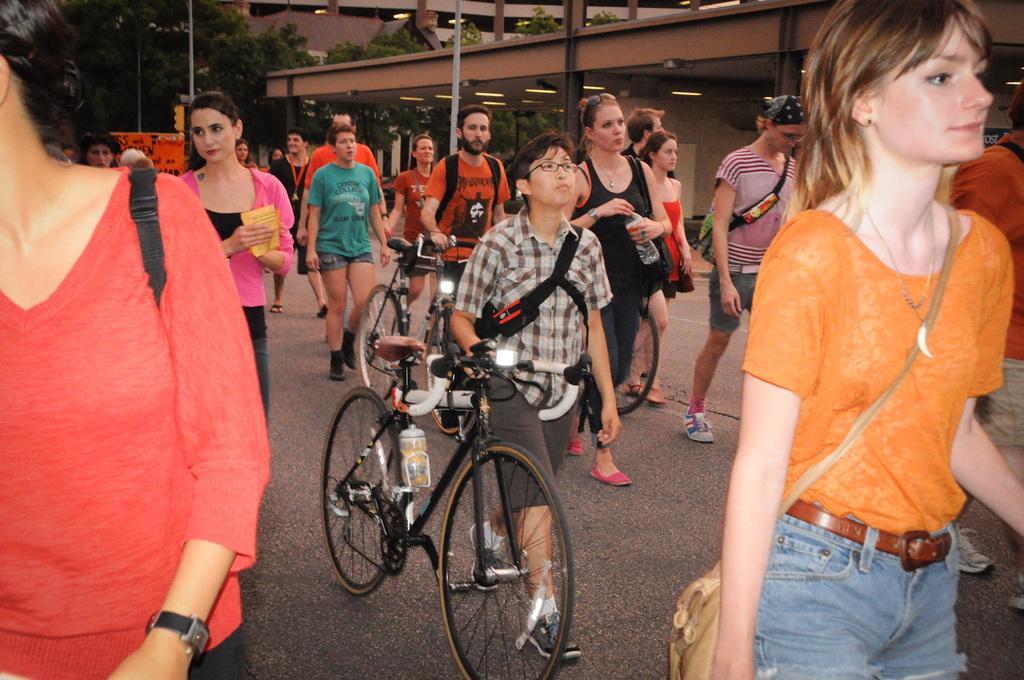In one or two sentences, can you explain what this image depicts? There are group of people walking and two persons are holding bicycles. I can see a water bottle attached to the bicycle. At background I can see trees and this looks like a building. This is the pole. I think this is the kind of banner. 